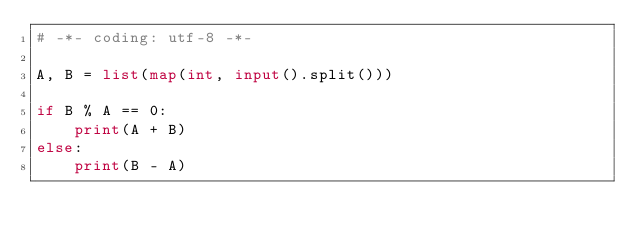<code> <loc_0><loc_0><loc_500><loc_500><_Python_># -*- coding: utf-8 -*-

A, B = list(map(int, input().split()))

if B % A == 0:
    print(A + B)
else:
    print(B - A)

</code> 